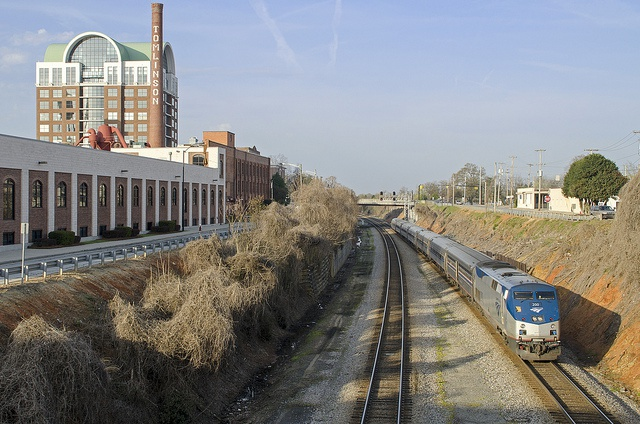Describe the objects in this image and their specific colors. I can see train in darkgray, gray, and black tones, car in darkgray, gray, and black tones, stop sign in darkgray, lightpink, salmon, and lightgray tones, and traffic light in darkgray, gray, olive, tan, and gold tones in this image. 